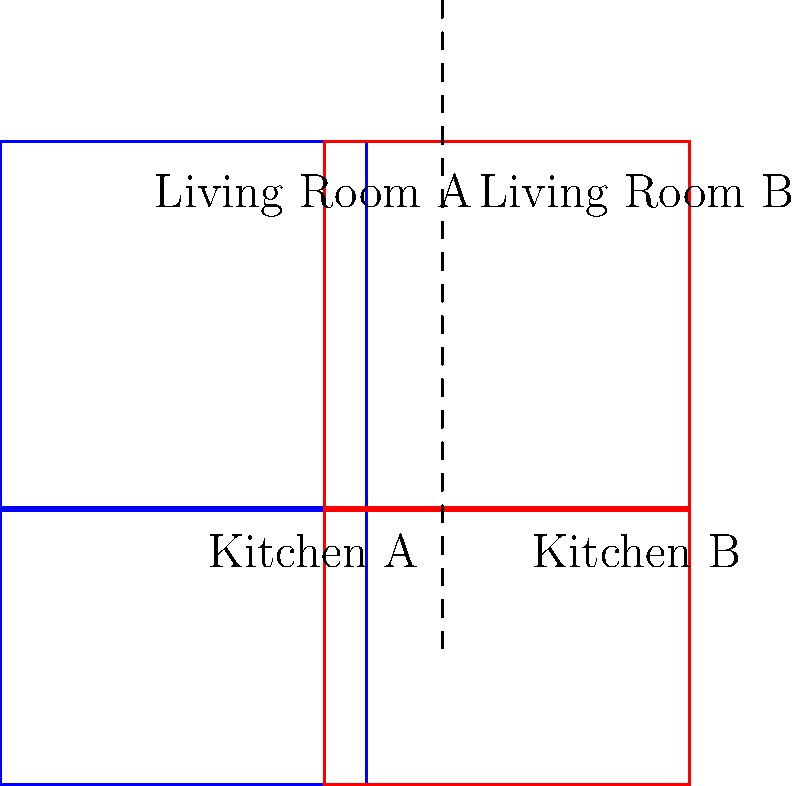Compare the floor plans of two home renovation options shown above. Which rooms are congruent to each other? To determine which rooms are congruent, we need to compare their shapes and sizes:

1. Kitchen A and Kitchen B:
   - Both are rectangles with the same dimensions
   - They have the same shape and size
   - Therefore, Kitchen A and Kitchen B are congruent

2. Living Room A and Living Room B:
   - Both are squares with the same dimensions
   - They have the same shape and size
   - Therefore, Living Room A and Living Room B are congruent

3. Comparing Kitchens to Living Rooms:
   - The kitchens are rectangles, while the living rooms are squares
   - The living rooms appear larger than the kitchens
   - Therefore, the kitchens are not congruent to the living rooms

In geometry, two figures are considered congruent if they have the same shape and size, meaning they can be superimposed on each other through translations, rotations, or reflections.
Answer: Kitchen A and Kitchen B; Living Room A and Living Room B 